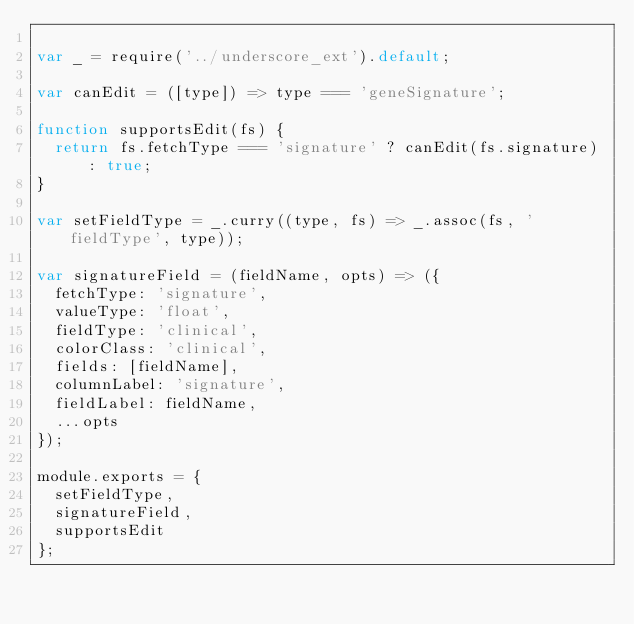<code> <loc_0><loc_0><loc_500><loc_500><_JavaScript_>
var _ = require('../underscore_ext').default;

var canEdit = ([type]) => type === 'geneSignature';

function supportsEdit(fs) {
	return fs.fetchType === 'signature' ? canEdit(fs.signature) : true;
}

var setFieldType = _.curry((type, fs) => _.assoc(fs, 'fieldType', type));

var signatureField = (fieldName, opts) => ({
	fetchType: 'signature',
	valueType: 'float',
	fieldType: 'clinical',
	colorClass: 'clinical',
	fields: [fieldName],
	columnLabel: 'signature',
	fieldLabel: fieldName,
	...opts
});

module.exports = {
	setFieldType,
	signatureField,
	supportsEdit
};
</code> 